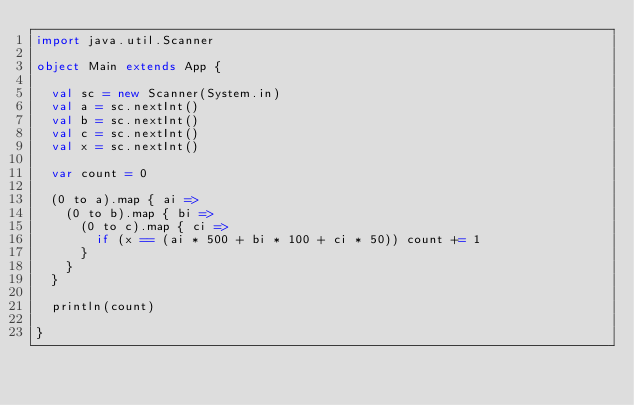<code> <loc_0><loc_0><loc_500><loc_500><_Scala_>import java.util.Scanner

object Main extends App {

  val sc = new Scanner(System.in)
  val a = sc.nextInt()
  val b = sc.nextInt()
  val c = sc.nextInt()
  val x = sc.nextInt()
  
  var count = 0

  (0 to a).map { ai =>
    (0 to b).map { bi =>
      (0 to c).map { ci =>
        if (x == (ai * 500 + bi * 100 + ci * 50)) count += 1
      }
    }
  }

  println(count)

}
</code> 